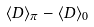<formula> <loc_0><loc_0><loc_500><loc_500>\langle D \rangle _ { \pi } - \langle D \rangle _ { 0 }</formula> 